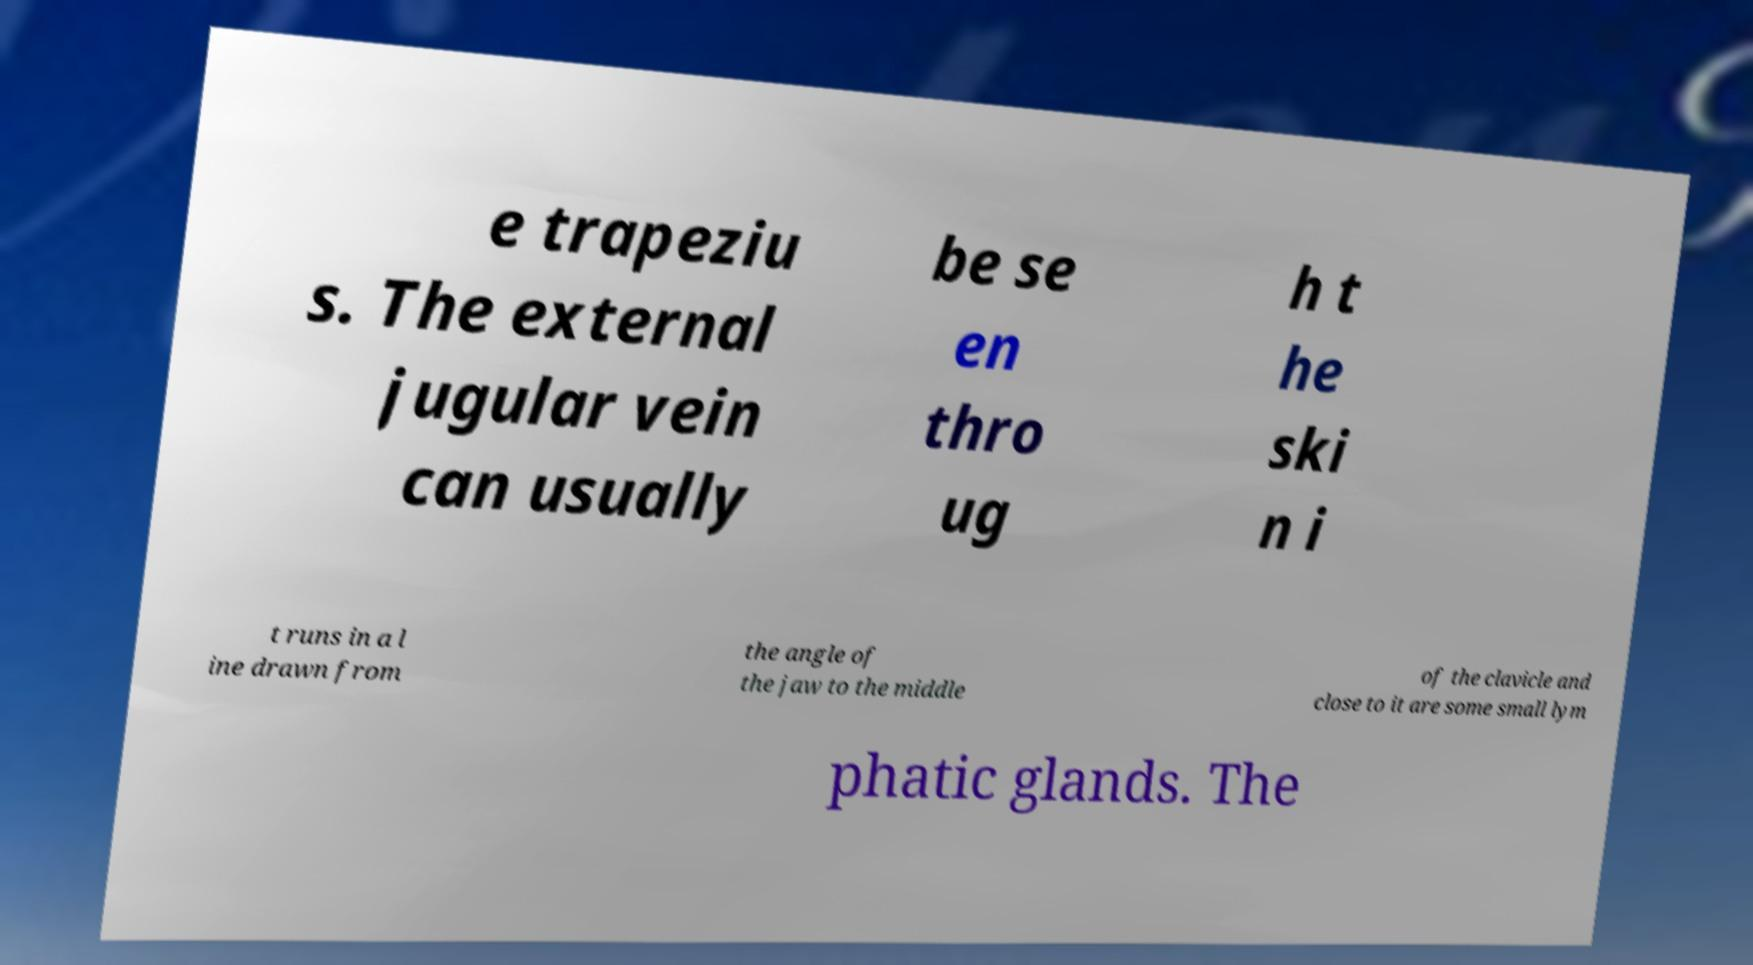There's text embedded in this image that I need extracted. Can you transcribe it verbatim? e trapeziu s. The external jugular vein can usually be se en thro ug h t he ski n i t runs in a l ine drawn from the angle of the jaw to the middle of the clavicle and close to it are some small lym phatic glands. The 